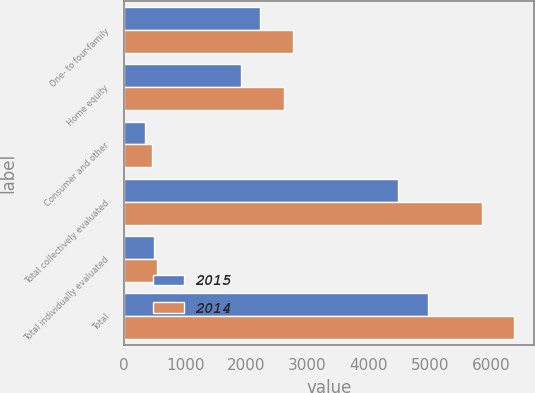<chart> <loc_0><loc_0><loc_500><loc_500><stacked_bar_chart><ecel><fcel>One- to four-family<fcel>Home equity<fcel>Consumer and other<fcel>Total collectively evaluated<fcel>Total individually evaluated<fcel>Total<nl><fcel>2015<fcel>2219<fcel>1915<fcel>344<fcel>4478<fcel>488<fcel>4966<nl><fcel>2014<fcel>2764<fcel>2625<fcel>461<fcel>5850<fcel>533<fcel>6383<nl></chart> 